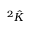<formula> <loc_0><loc_0><loc_500><loc_500>^ { 2 } { \hat { K } }</formula> 